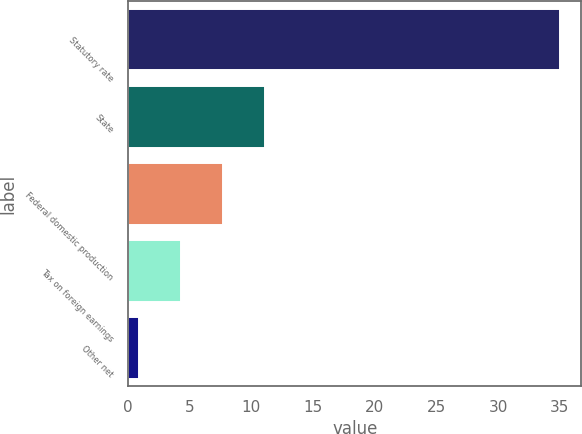Convert chart. <chart><loc_0><loc_0><loc_500><loc_500><bar_chart><fcel>Statutory rate<fcel>State<fcel>Federal domestic production<fcel>Tax on foreign earnings<fcel>Other net<nl><fcel>35<fcel>11.13<fcel>7.72<fcel>4.31<fcel>0.9<nl></chart> 